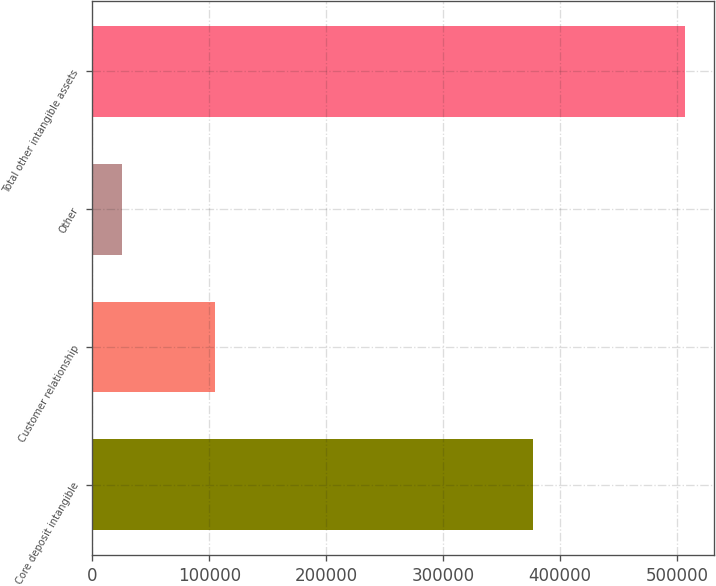Convert chart. <chart><loc_0><loc_0><loc_500><loc_500><bar_chart><fcel>Core deposit intangible<fcel>Customer relationship<fcel>Other<fcel>Total other intangible assets<nl><fcel>376846<fcel>104574<fcel>25164<fcel>506584<nl></chart> 